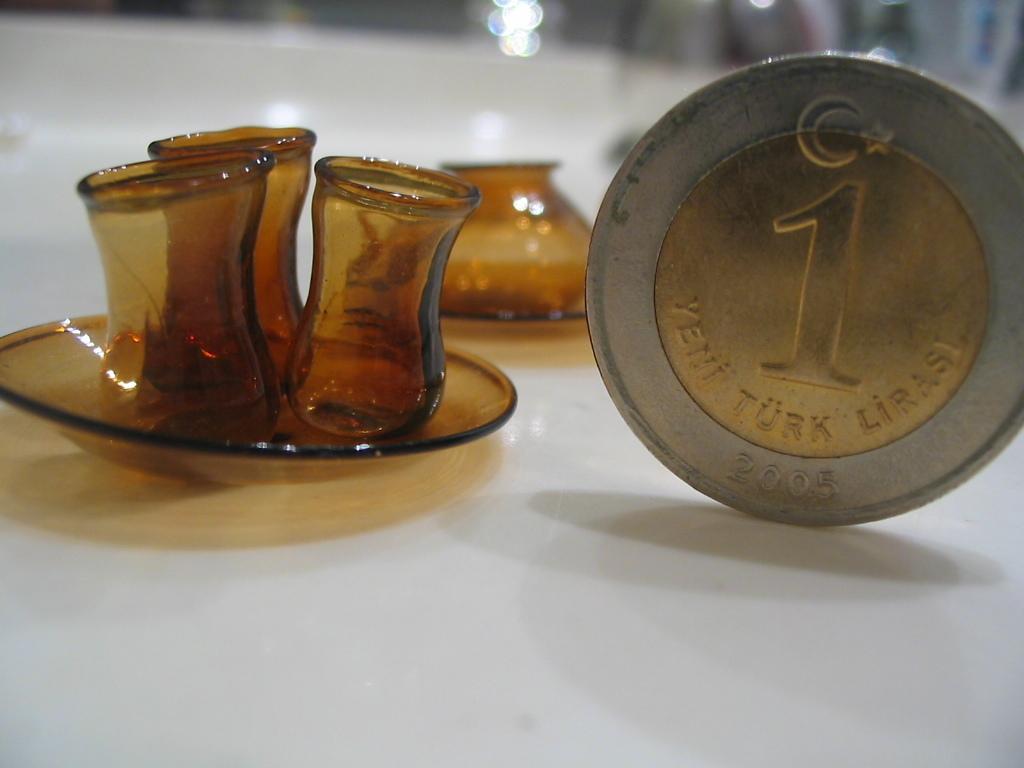Can you describe this image briefly? In this image there is a coin on the ground, there are glasses, there is a saucer on the ground, the background of the image is blurred. 